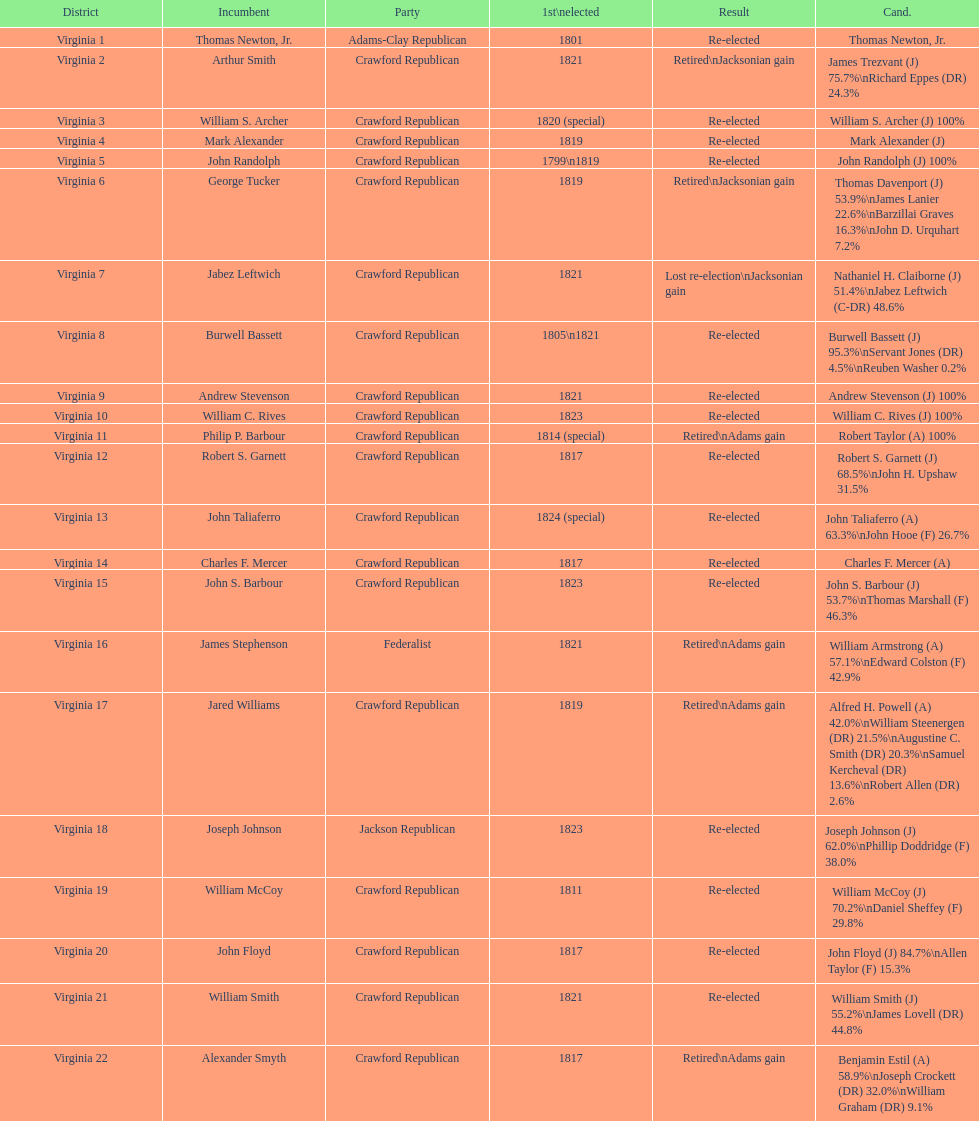Who was the next incumbent after john randolph? George Tucker. 